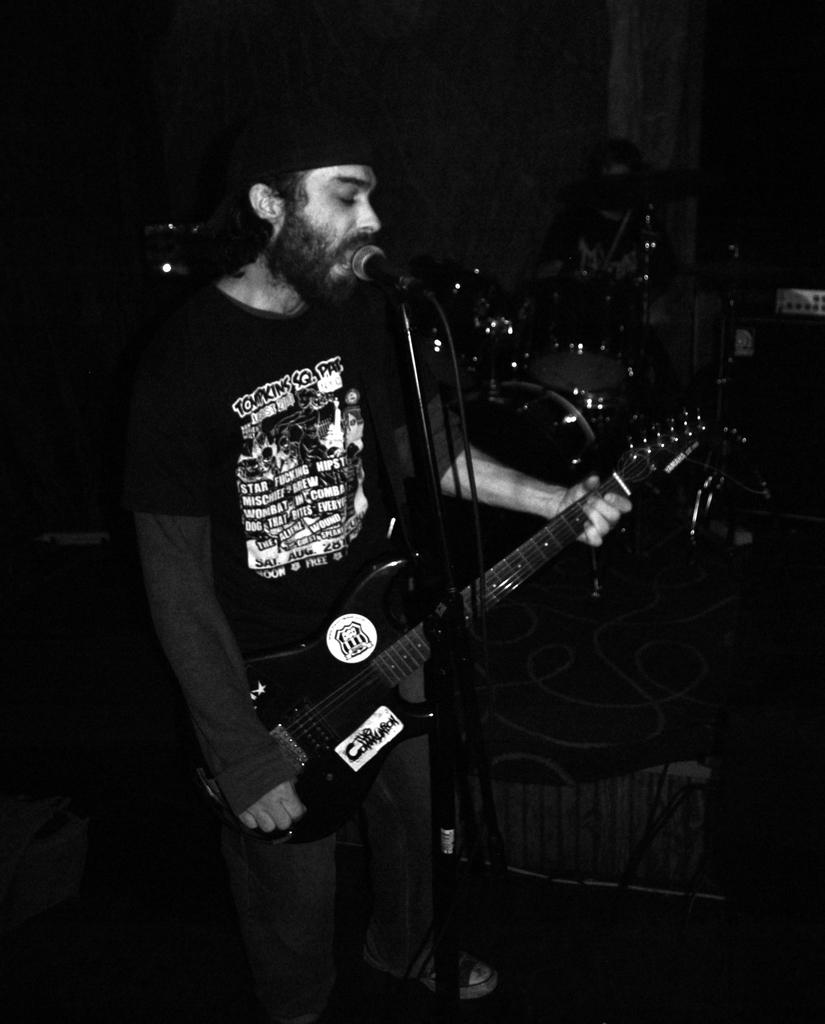What is the main subject of the image? There is a man in the image. What is the man doing in the image? The man is standing and singing. What instrument is the man holding in the image? The man is holding a guitar in his hands. What device is in front of the man? There is a microphone in front of the man. What other musical instruments can be seen in the image? Musical drums are visible in the image. Can you tell me how many bones the man is holding in his hands? There are no bones visible in the image; the man is holding a guitar. What type of gate can be seen in the image? There is no gate present in the image. 